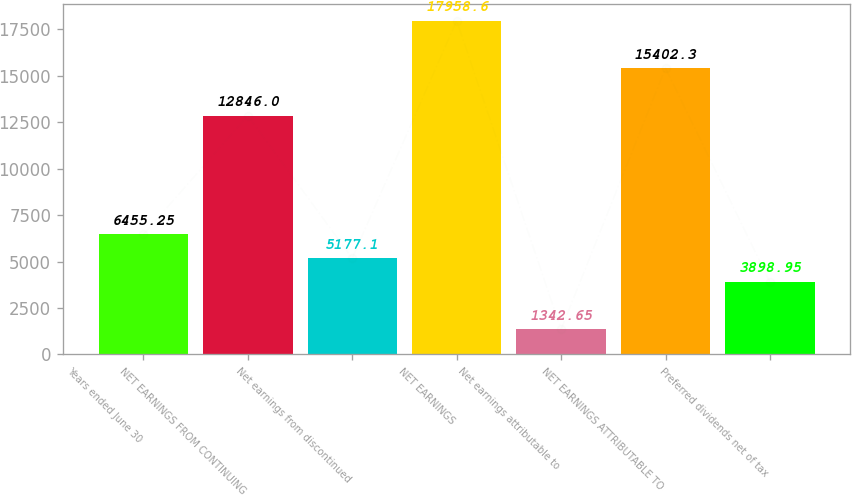Convert chart to OTSL. <chart><loc_0><loc_0><loc_500><loc_500><bar_chart><fcel>Years ended June 30<fcel>NET EARNINGS FROM CONTINUING<fcel>Net earnings from discontinued<fcel>NET EARNINGS<fcel>Net earnings attributable to<fcel>NET EARNINGS ATTRIBUTABLE TO<fcel>Preferred dividends net of tax<nl><fcel>6455.25<fcel>12846<fcel>5177.1<fcel>17958.6<fcel>1342.65<fcel>15402.3<fcel>3898.95<nl></chart> 